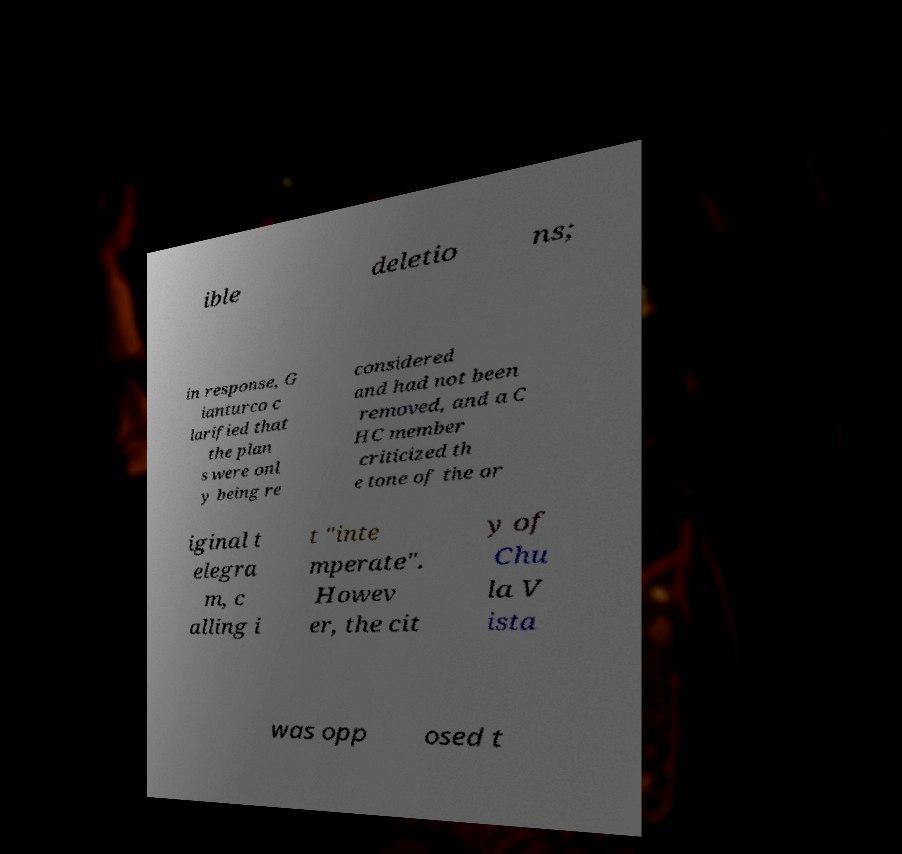What messages or text are displayed in this image? I need them in a readable, typed format. ible deletio ns; in response, G ianturco c larified that the plan s were onl y being re considered and had not been removed, and a C HC member criticized th e tone of the or iginal t elegra m, c alling i t "inte mperate". Howev er, the cit y of Chu la V ista was opp osed t 